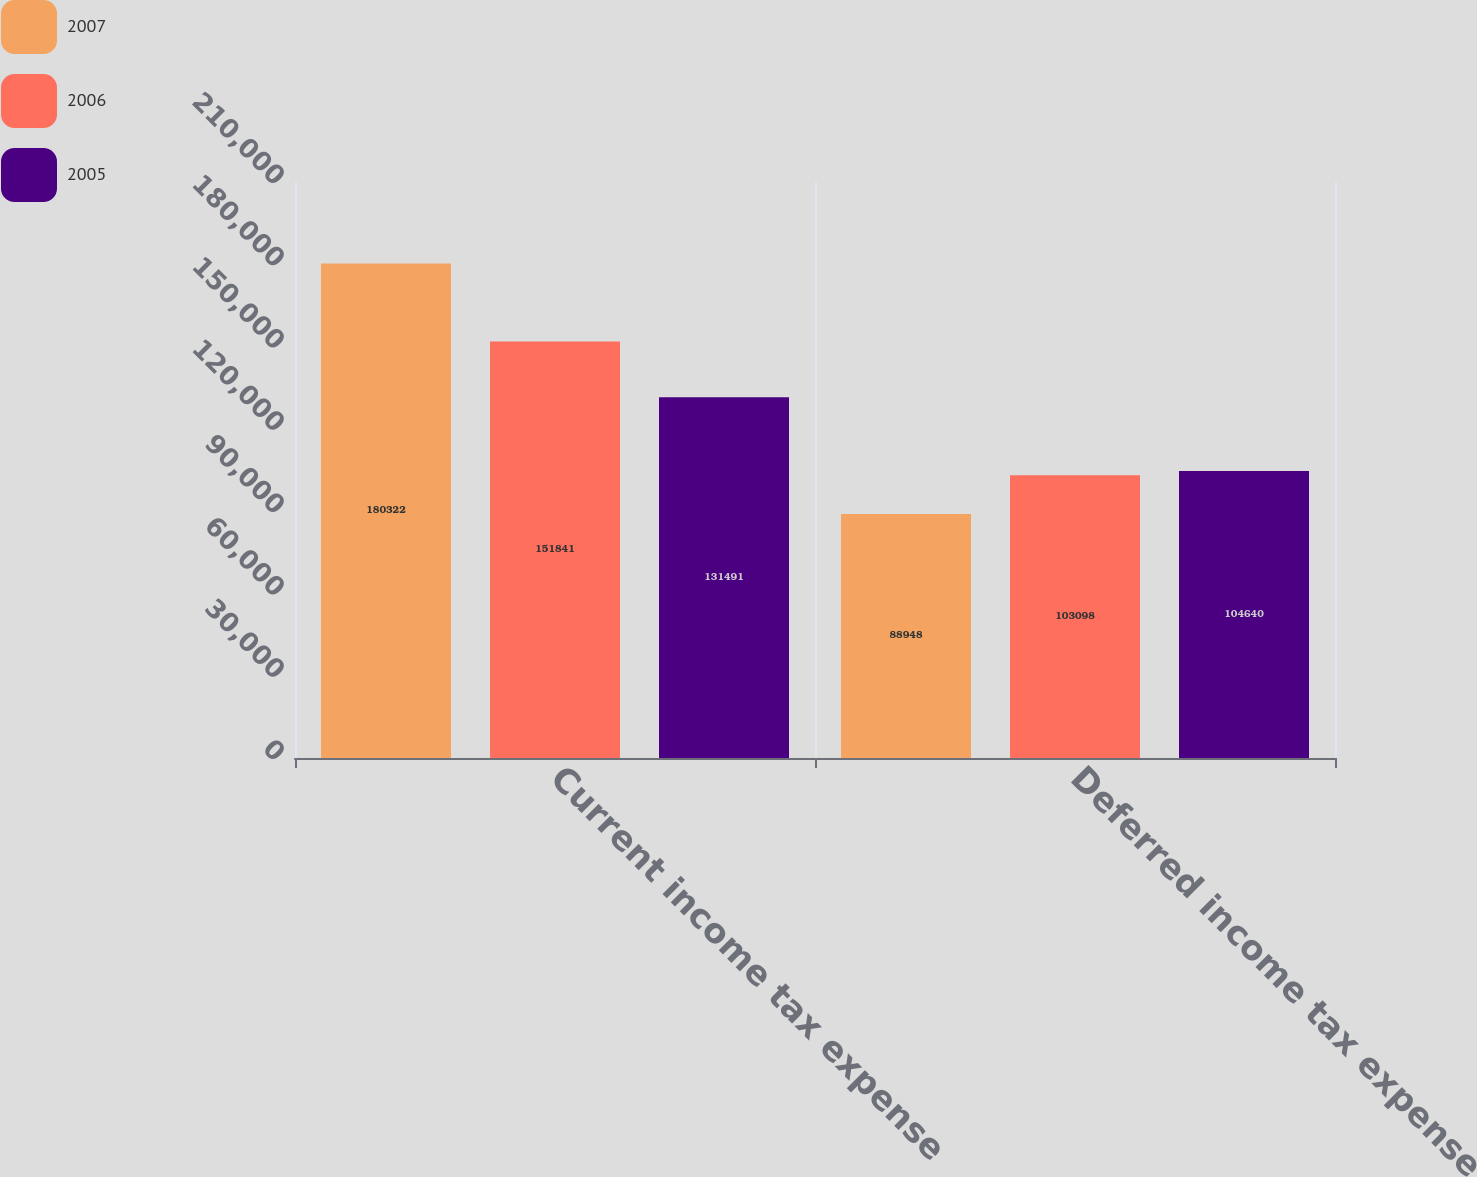Convert chart. <chart><loc_0><loc_0><loc_500><loc_500><stacked_bar_chart><ecel><fcel>Current income tax expense<fcel>Deferred income tax expense<nl><fcel>2007<fcel>180322<fcel>88948<nl><fcel>2006<fcel>151841<fcel>103098<nl><fcel>2005<fcel>131491<fcel>104640<nl></chart> 